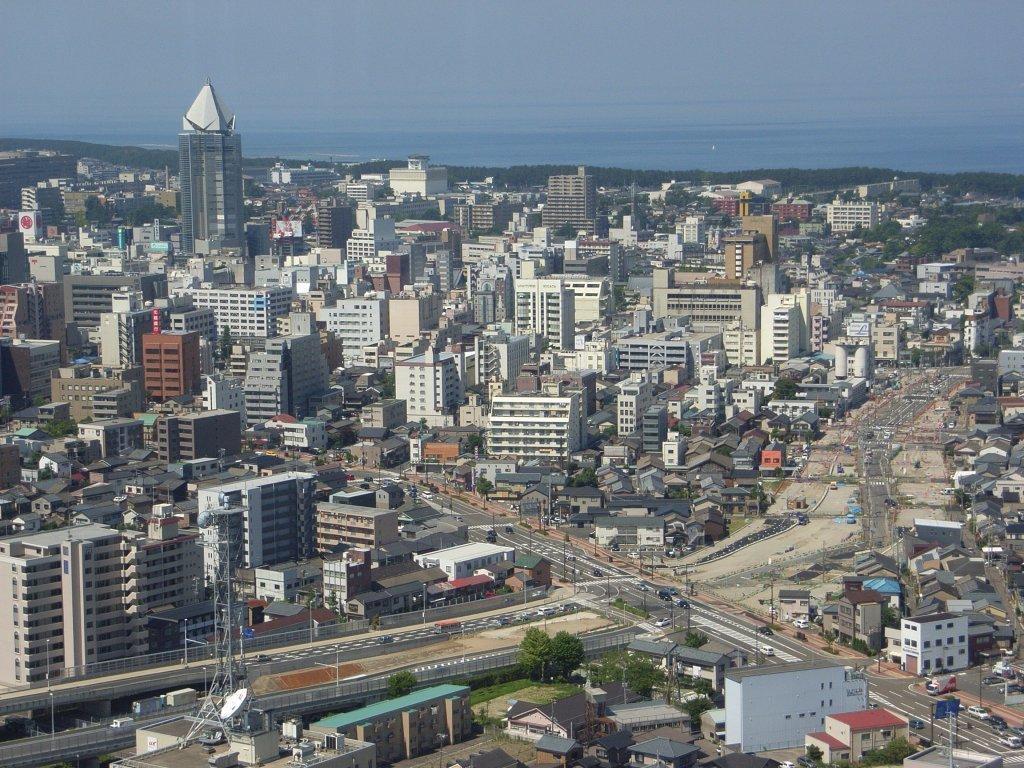Please provide a concise description of this image. In this image there are some buildings in middle of this image and some buildings are at bottom of this image. There is a road at bottom of this image and there is a sky at top of this image , and there are some towers at bottom left corner of this image. 